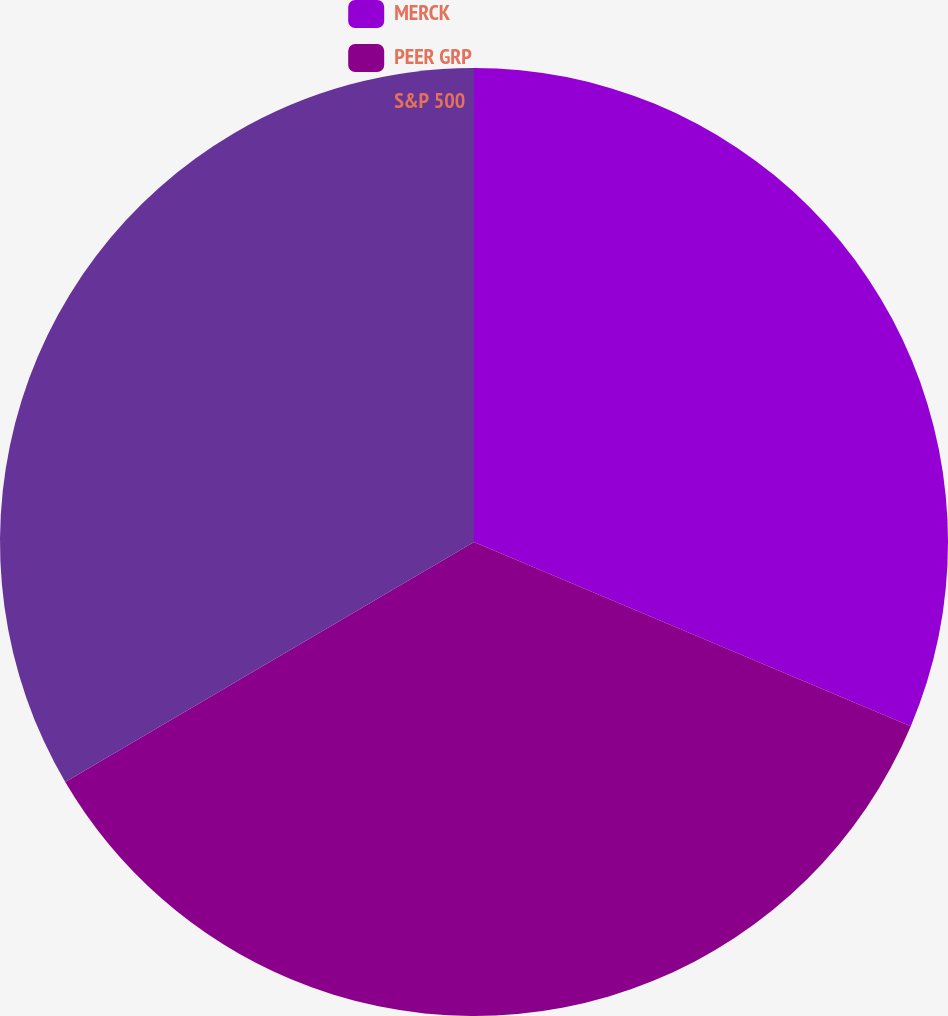Convert chart. <chart><loc_0><loc_0><loc_500><loc_500><pie_chart><fcel>MERCK<fcel>PEER GRP<fcel>S&P 500<nl><fcel>31.35%<fcel>35.2%<fcel>33.45%<nl></chart> 